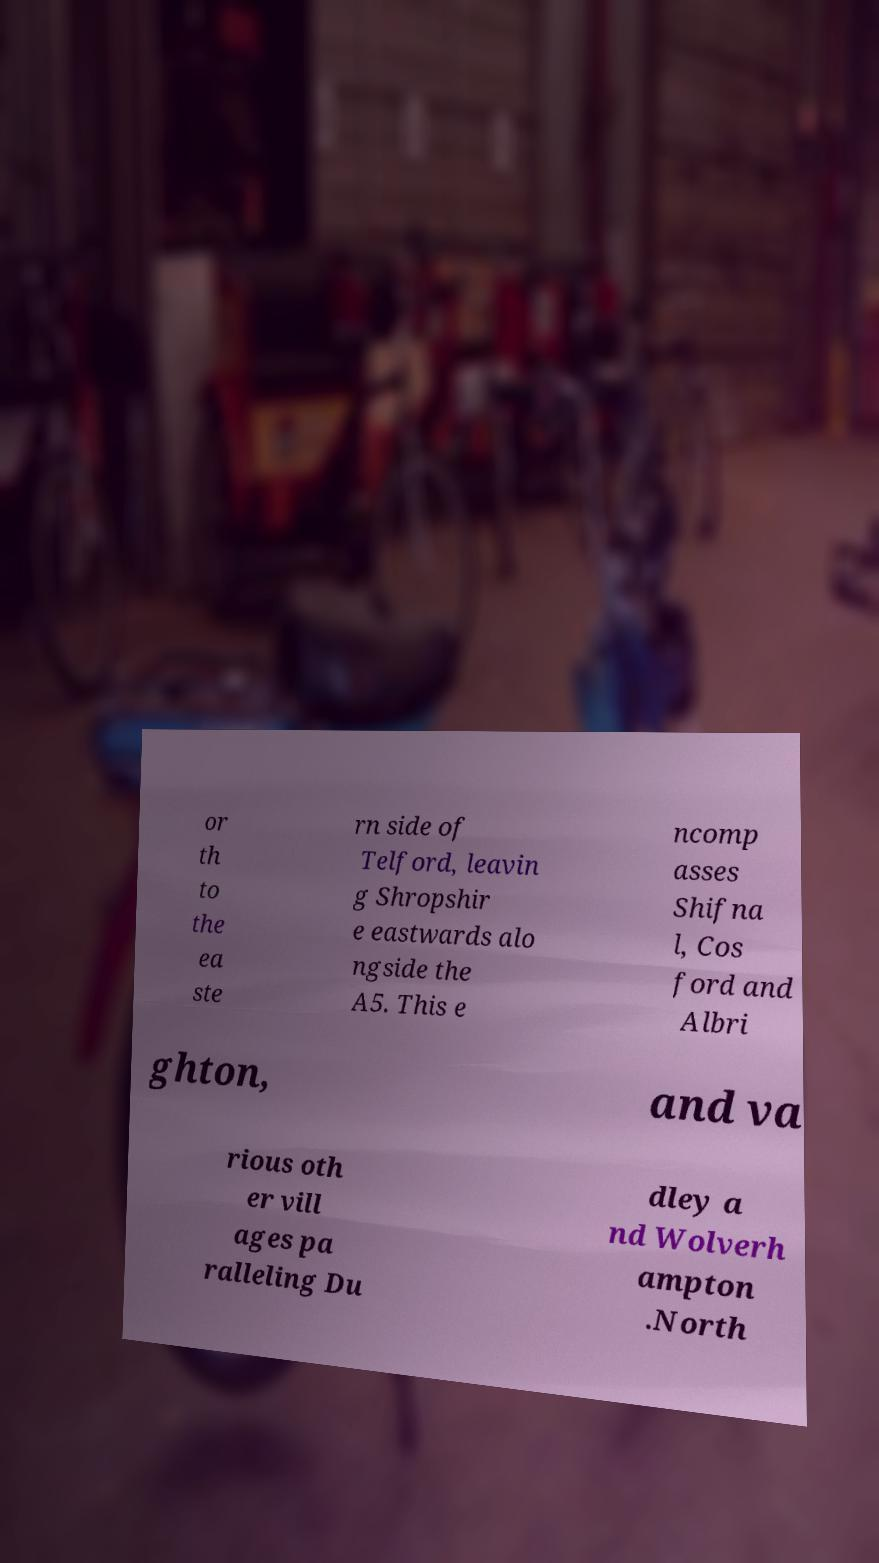I need the written content from this picture converted into text. Can you do that? or th to the ea ste rn side of Telford, leavin g Shropshir e eastwards alo ngside the A5. This e ncomp asses Shifna l, Cos ford and Albri ghton, and va rious oth er vill ages pa ralleling Du dley a nd Wolverh ampton .North 